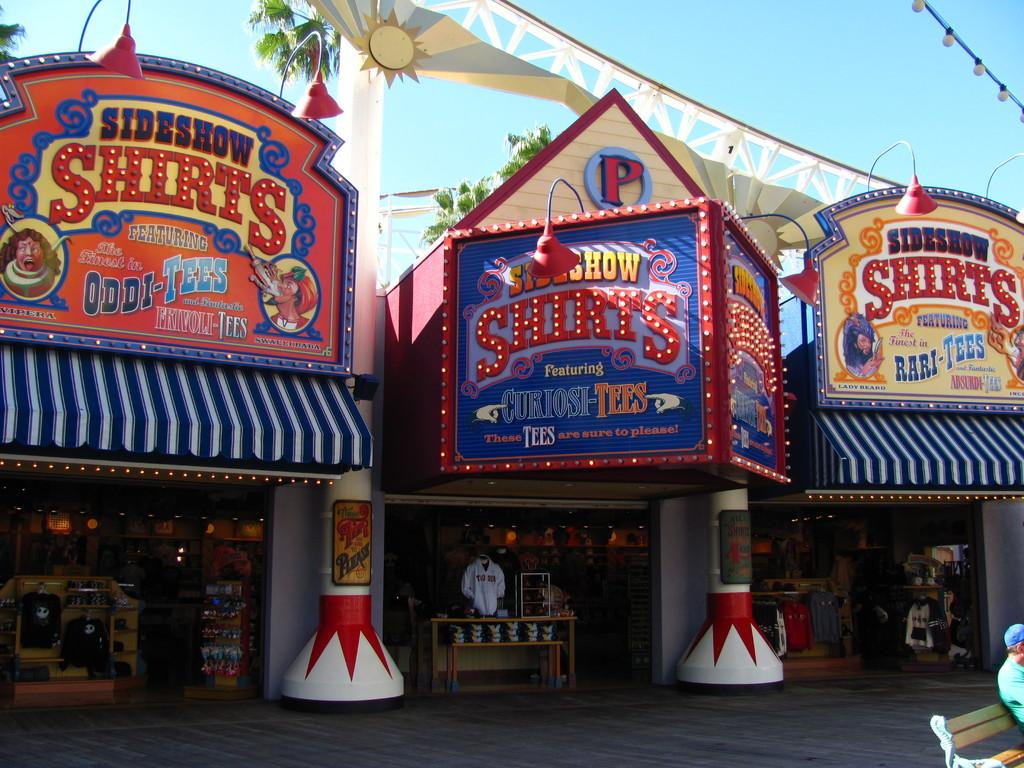What can be seen in the middle of the image? There are stalls in the middle of the image. What is written or displayed on the stalls? There is text on the boards of the stalls. What can be seen in the background of the image? There are trees and the sky visible in the background of the image. How many dolls are sitting on the tomatoes in the image? There are no dolls or tomatoes present in the image. 